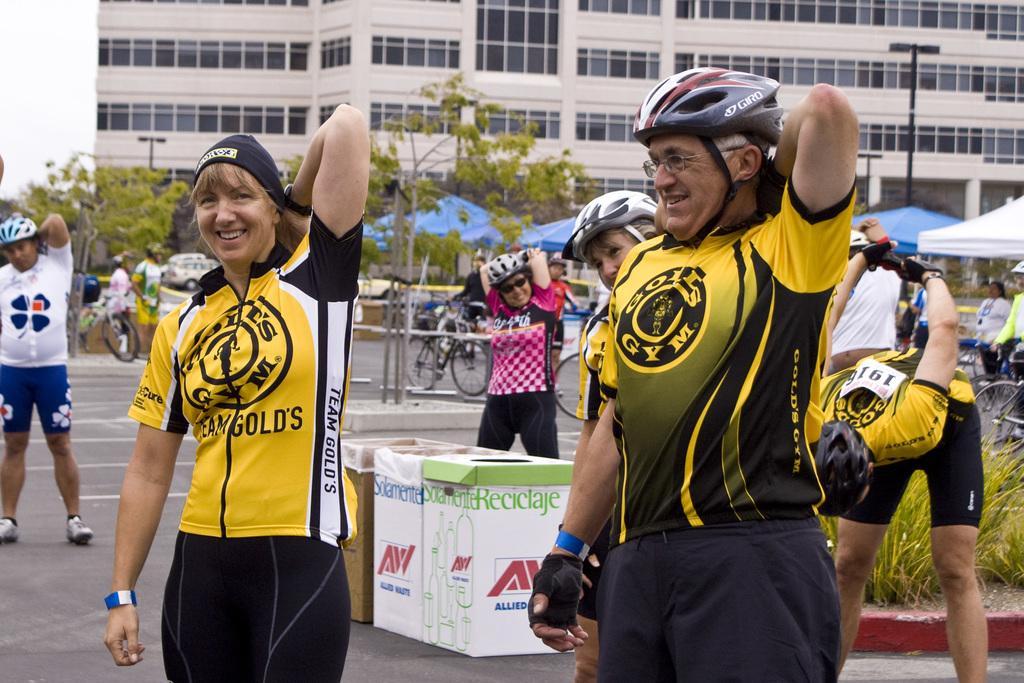Can you describe this image briefly? These people are standing and this person wore cap and we can see card board boxes on the road. Background we can see trees,tents,bicycles,buildings and sky. 